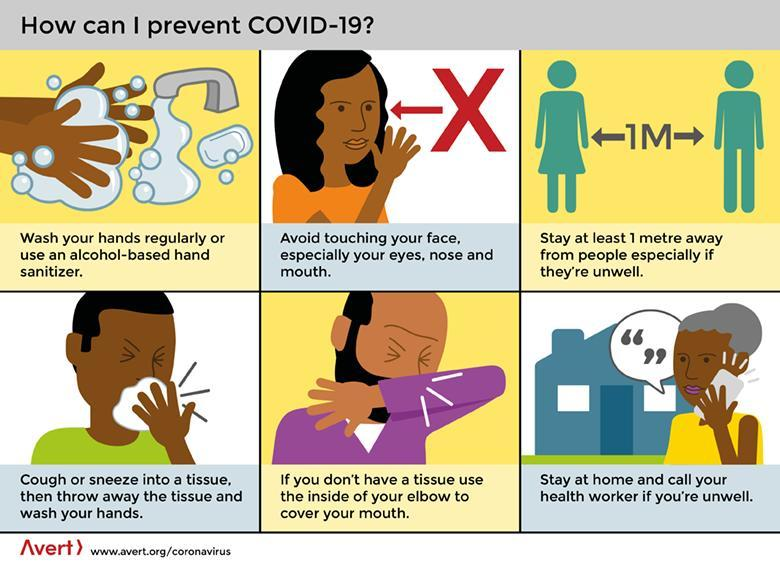What is the tip given at the end of the first row?
Answer the question with a short phrase. stay at least 1 metre away from people especially if they're unwell What is the tip given at the beginning of the second row? cough or sneeze into a tissue. then throw away the tissue and wash your hands How many tips are given in this infographic to prevent COVID-19? 6 What is the tip given in the middle of the second row? if you don't have a tissue use the inside of your elbow to cover your mouth 